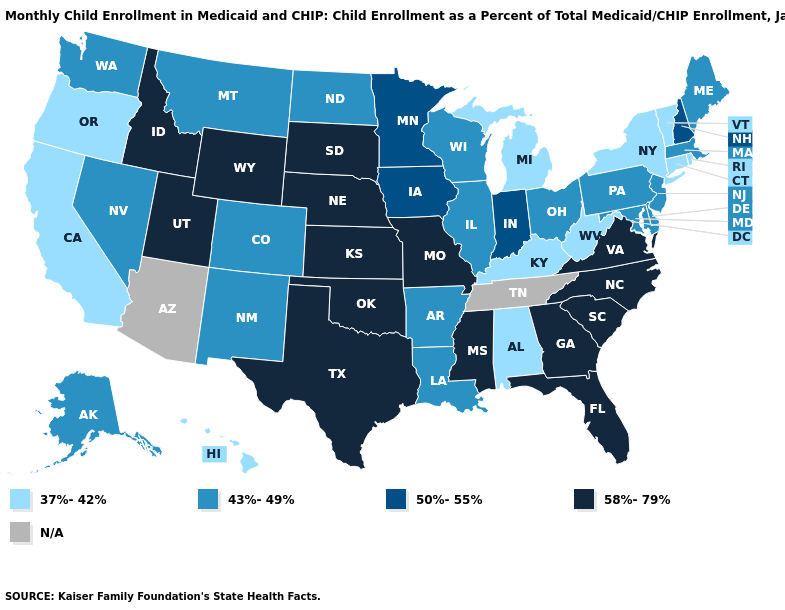What is the value of Louisiana?
Answer briefly. 43%-49%. Name the states that have a value in the range 58%-79%?
Write a very short answer. Florida, Georgia, Idaho, Kansas, Mississippi, Missouri, Nebraska, North Carolina, Oklahoma, South Carolina, South Dakota, Texas, Utah, Virginia, Wyoming. What is the value of Maryland?
Be succinct. 43%-49%. What is the lowest value in states that border South Dakota?
Give a very brief answer. 43%-49%. Among the states that border Tennessee , does Missouri have the lowest value?
Short answer required. No. Does North Dakota have the highest value in the USA?
Write a very short answer. No. What is the value of Texas?
Write a very short answer. 58%-79%. Does Alabama have the lowest value in the South?
Concise answer only. Yes. What is the value of Alabama?
Short answer required. 37%-42%. Among the states that border Nevada , which have the highest value?
Write a very short answer. Idaho, Utah. Name the states that have a value in the range 58%-79%?
Write a very short answer. Florida, Georgia, Idaho, Kansas, Mississippi, Missouri, Nebraska, North Carolina, Oklahoma, South Carolina, South Dakota, Texas, Utah, Virginia, Wyoming. What is the value of Virginia?
Be succinct. 58%-79%. Name the states that have a value in the range 37%-42%?
Quick response, please. Alabama, California, Connecticut, Hawaii, Kentucky, Michigan, New York, Oregon, Rhode Island, Vermont, West Virginia. What is the lowest value in states that border North Carolina?
Write a very short answer. 58%-79%. Among the states that border Alabama , which have the lowest value?
Keep it brief. Florida, Georgia, Mississippi. 